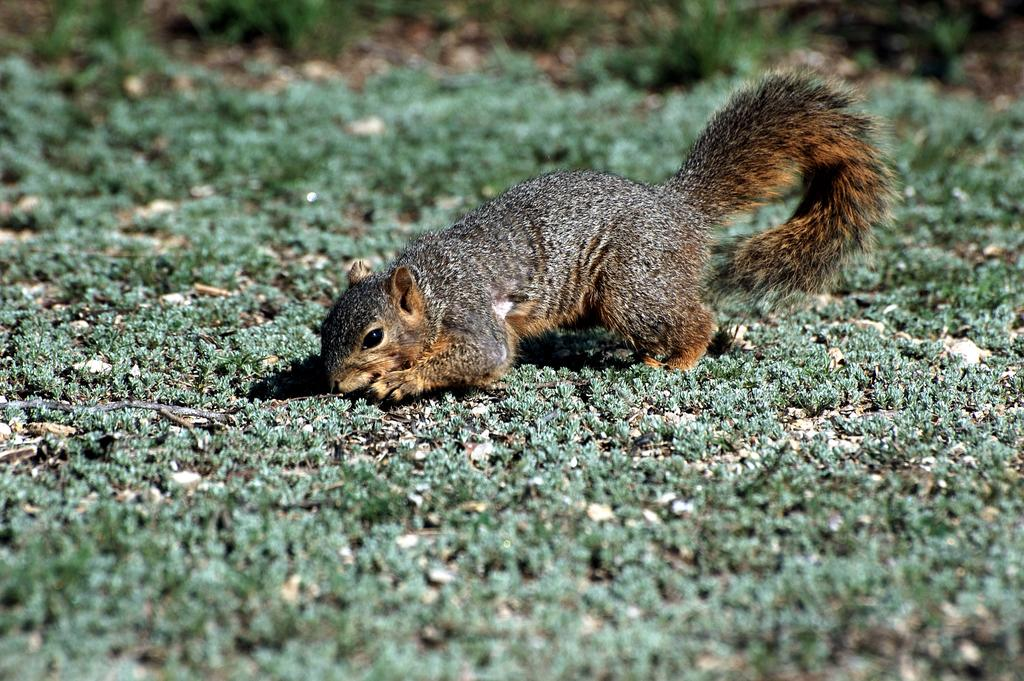What animal can be seen in the picture? There is a squirrel in the picture. What is the squirrel laying on? The squirrel is laying on a grass surface. What subject is the squirrel teaching in the picture? There is no indication in the image that the squirrel is teaching any subject. 